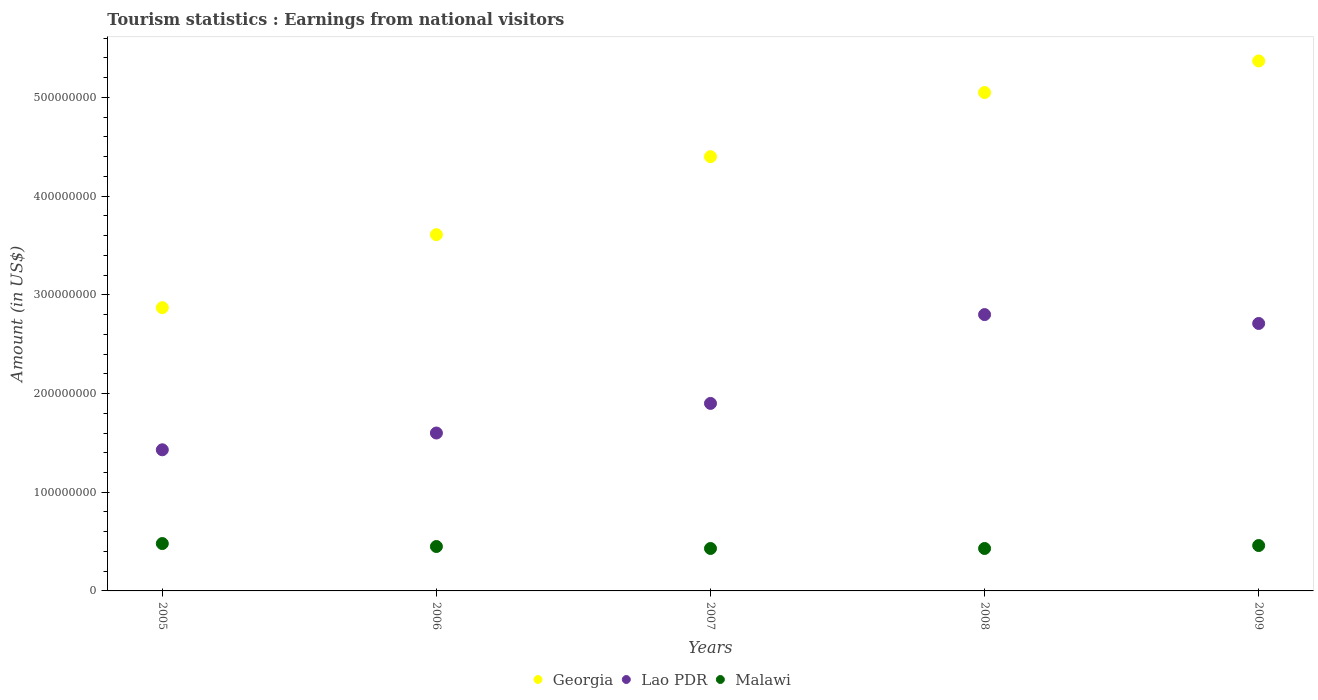What is the earnings from national visitors in Georgia in 2009?
Provide a succinct answer. 5.37e+08. Across all years, what is the maximum earnings from national visitors in Malawi?
Offer a terse response. 4.80e+07. Across all years, what is the minimum earnings from national visitors in Lao PDR?
Your answer should be compact. 1.43e+08. What is the total earnings from national visitors in Malawi in the graph?
Your answer should be compact. 2.25e+08. What is the difference between the earnings from national visitors in Lao PDR in 2006 and that in 2008?
Your answer should be very brief. -1.20e+08. What is the difference between the earnings from national visitors in Georgia in 2006 and the earnings from national visitors in Lao PDR in 2005?
Ensure brevity in your answer.  2.18e+08. What is the average earnings from national visitors in Georgia per year?
Provide a succinct answer. 4.26e+08. In the year 2005, what is the difference between the earnings from national visitors in Malawi and earnings from national visitors in Lao PDR?
Offer a very short reply. -9.50e+07. What is the ratio of the earnings from national visitors in Georgia in 2006 to that in 2008?
Offer a very short reply. 0.71. Is the difference between the earnings from national visitors in Malawi in 2007 and 2008 greater than the difference between the earnings from national visitors in Lao PDR in 2007 and 2008?
Ensure brevity in your answer.  Yes. What is the difference between the highest and the second highest earnings from national visitors in Georgia?
Make the answer very short. 3.20e+07. What is the difference between the highest and the lowest earnings from national visitors in Georgia?
Offer a very short reply. 2.50e+08. Is the sum of the earnings from national visitors in Georgia in 2005 and 2009 greater than the maximum earnings from national visitors in Malawi across all years?
Provide a short and direct response. Yes. Is the earnings from national visitors in Malawi strictly greater than the earnings from national visitors in Lao PDR over the years?
Your answer should be compact. No. How many dotlines are there?
Offer a terse response. 3. How many years are there in the graph?
Offer a very short reply. 5. What is the difference between two consecutive major ticks on the Y-axis?
Give a very brief answer. 1.00e+08. Does the graph contain grids?
Keep it short and to the point. No. Where does the legend appear in the graph?
Your response must be concise. Bottom center. What is the title of the graph?
Keep it short and to the point. Tourism statistics : Earnings from national visitors. What is the label or title of the X-axis?
Provide a short and direct response. Years. What is the Amount (in US$) of Georgia in 2005?
Keep it short and to the point. 2.87e+08. What is the Amount (in US$) in Lao PDR in 2005?
Your answer should be very brief. 1.43e+08. What is the Amount (in US$) in Malawi in 2005?
Give a very brief answer. 4.80e+07. What is the Amount (in US$) of Georgia in 2006?
Keep it short and to the point. 3.61e+08. What is the Amount (in US$) in Lao PDR in 2006?
Offer a terse response. 1.60e+08. What is the Amount (in US$) of Malawi in 2006?
Your answer should be very brief. 4.50e+07. What is the Amount (in US$) of Georgia in 2007?
Ensure brevity in your answer.  4.40e+08. What is the Amount (in US$) of Lao PDR in 2007?
Offer a very short reply. 1.90e+08. What is the Amount (in US$) of Malawi in 2007?
Give a very brief answer. 4.30e+07. What is the Amount (in US$) in Georgia in 2008?
Offer a terse response. 5.05e+08. What is the Amount (in US$) in Lao PDR in 2008?
Your answer should be compact. 2.80e+08. What is the Amount (in US$) in Malawi in 2008?
Provide a succinct answer. 4.30e+07. What is the Amount (in US$) in Georgia in 2009?
Your response must be concise. 5.37e+08. What is the Amount (in US$) in Lao PDR in 2009?
Keep it short and to the point. 2.71e+08. What is the Amount (in US$) of Malawi in 2009?
Provide a succinct answer. 4.60e+07. Across all years, what is the maximum Amount (in US$) of Georgia?
Offer a terse response. 5.37e+08. Across all years, what is the maximum Amount (in US$) in Lao PDR?
Ensure brevity in your answer.  2.80e+08. Across all years, what is the maximum Amount (in US$) in Malawi?
Provide a succinct answer. 4.80e+07. Across all years, what is the minimum Amount (in US$) in Georgia?
Give a very brief answer. 2.87e+08. Across all years, what is the minimum Amount (in US$) in Lao PDR?
Offer a very short reply. 1.43e+08. Across all years, what is the minimum Amount (in US$) in Malawi?
Your answer should be very brief. 4.30e+07. What is the total Amount (in US$) of Georgia in the graph?
Keep it short and to the point. 2.13e+09. What is the total Amount (in US$) of Lao PDR in the graph?
Offer a very short reply. 1.04e+09. What is the total Amount (in US$) of Malawi in the graph?
Offer a terse response. 2.25e+08. What is the difference between the Amount (in US$) in Georgia in 2005 and that in 2006?
Provide a succinct answer. -7.40e+07. What is the difference between the Amount (in US$) in Lao PDR in 2005 and that in 2006?
Offer a very short reply. -1.70e+07. What is the difference between the Amount (in US$) in Georgia in 2005 and that in 2007?
Give a very brief answer. -1.53e+08. What is the difference between the Amount (in US$) in Lao PDR in 2005 and that in 2007?
Keep it short and to the point. -4.70e+07. What is the difference between the Amount (in US$) in Georgia in 2005 and that in 2008?
Keep it short and to the point. -2.18e+08. What is the difference between the Amount (in US$) in Lao PDR in 2005 and that in 2008?
Your answer should be very brief. -1.37e+08. What is the difference between the Amount (in US$) of Malawi in 2005 and that in 2008?
Offer a very short reply. 5.00e+06. What is the difference between the Amount (in US$) in Georgia in 2005 and that in 2009?
Keep it short and to the point. -2.50e+08. What is the difference between the Amount (in US$) of Lao PDR in 2005 and that in 2009?
Keep it short and to the point. -1.28e+08. What is the difference between the Amount (in US$) of Georgia in 2006 and that in 2007?
Provide a short and direct response. -7.90e+07. What is the difference between the Amount (in US$) of Lao PDR in 2006 and that in 2007?
Offer a terse response. -3.00e+07. What is the difference between the Amount (in US$) of Georgia in 2006 and that in 2008?
Your answer should be compact. -1.44e+08. What is the difference between the Amount (in US$) in Lao PDR in 2006 and that in 2008?
Give a very brief answer. -1.20e+08. What is the difference between the Amount (in US$) of Malawi in 2006 and that in 2008?
Keep it short and to the point. 2.00e+06. What is the difference between the Amount (in US$) of Georgia in 2006 and that in 2009?
Ensure brevity in your answer.  -1.76e+08. What is the difference between the Amount (in US$) of Lao PDR in 2006 and that in 2009?
Your answer should be compact. -1.11e+08. What is the difference between the Amount (in US$) of Malawi in 2006 and that in 2009?
Your answer should be compact. -1.00e+06. What is the difference between the Amount (in US$) of Georgia in 2007 and that in 2008?
Your response must be concise. -6.50e+07. What is the difference between the Amount (in US$) in Lao PDR in 2007 and that in 2008?
Provide a short and direct response. -9.00e+07. What is the difference between the Amount (in US$) in Georgia in 2007 and that in 2009?
Make the answer very short. -9.70e+07. What is the difference between the Amount (in US$) of Lao PDR in 2007 and that in 2009?
Give a very brief answer. -8.10e+07. What is the difference between the Amount (in US$) in Malawi in 2007 and that in 2009?
Your response must be concise. -3.00e+06. What is the difference between the Amount (in US$) in Georgia in 2008 and that in 2009?
Your response must be concise. -3.20e+07. What is the difference between the Amount (in US$) of Lao PDR in 2008 and that in 2009?
Your answer should be very brief. 9.00e+06. What is the difference between the Amount (in US$) in Malawi in 2008 and that in 2009?
Make the answer very short. -3.00e+06. What is the difference between the Amount (in US$) of Georgia in 2005 and the Amount (in US$) of Lao PDR in 2006?
Keep it short and to the point. 1.27e+08. What is the difference between the Amount (in US$) of Georgia in 2005 and the Amount (in US$) of Malawi in 2006?
Provide a succinct answer. 2.42e+08. What is the difference between the Amount (in US$) in Lao PDR in 2005 and the Amount (in US$) in Malawi in 2006?
Provide a short and direct response. 9.80e+07. What is the difference between the Amount (in US$) of Georgia in 2005 and the Amount (in US$) of Lao PDR in 2007?
Make the answer very short. 9.70e+07. What is the difference between the Amount (in US$) in Georgia in 2005 and the Amount (in US$) in Malawi in 2007?
Your answer should be very brief. 2.44e+08. What is the difference between the Amount (in US$) of Georgia in 2005 and the Amount (in US$) of Malawi in 2008?
Give a very brief answer. 2.44e+08. What is the difference between the Amount (in US$) of Georgia in 2005 and the Amount (in US$) of Lao PDR in 2009?
Provide a succinct answer. 1.60e+07. What is the difference between the Amount (in US$) of Georgia in 2005 and the Amount (in US$) of Malawi in 2009?
Provide a short and direct response. 2.41e+08. What is the difference between the Amount (in US$) of Lao PDR in 2005 and the Amount (in US$) of Malawi in 2009?
Provide a short and direct response. 9.70e+07. What is the difference between the Amount (in US$) in Georgia in 2006 and the Amount (in US$) in Lao PDR in 2007?
Make the answer very short. 1.71e+08. What is the difference between the Amount (in US$) in Georgia in 2006 and the Amount (in US$) in Malawi in 2007?
Your answer should be very brief. 3.18e+08. What is the difference between the Amount (in US$) of Lao PDR in 2006 and the Amount (in US$) of Malawi in 2007?
Offer a very short reply. 1.17e+08. What is the difference between the Amount (in US$) in Georgia in 2006 and the Amount (in US$) in Lao PDR in 2008?
Your answer should be compact. 8.10e+07. What is the difference between the Amount (in US$) of Georgia in 2006 and the Amount (in US$) of Malawi in 2008?
Your answer should be compact. 3.18e+08. What is the difference between the Amount (in US$) of Lao PDR in 2006 and the Amount (in US$) of Malawi in 2008?
Make the answer very short. 1.17e+08. What is the difference between the Amount (in US$) in Georgia in 2006 and the Amount (in US$) in Lao PDR in 2009?
Give a very brief answer. 9.00e+07. What is the difference between the Amount (in US$) of Georgia in 2006 and the Amount (in US$) of Malawi in 2009?
Provide a short and direct response. 3.15e+08. What is the difference between the Amount (in US$) in Lao PDR in 2006 and the Amount (in US$) in Malawi in 2009?
Offer a very short reply. 1.14e+08. What is the difference between the Amount (in US$) of Georgia in 2007 and the Amount (in US$) of Lao PDR in 2008?
Your answer should be compact. 1.60e+08. What is the difference between the Amount (in US$) of Georgia in 2007 and the Amount (in US$) of Malawi in 2008?
Give a very brief answer. 3.97e+08. What is the difference between the Amount (in US$) of Lao PDR in 2007 and the Amount (in US$) of Malawi in 2008?
Offer a terse response. 1.47e+08. What is the difference between the Amount (in US$) of Georgia in 2007 and the Amount (in US$) of Lao PDR in 2009?
Offer a terse response. 1.69e+08. What is the difference between the Amount (in US$) in Georgia in 2007 and the Amount (in US$) in Malawi in 2009?
Your answer should be very brief. 3.94e+08. What is the difference between the Amount (in US$) in Lao PDR in 2007 and the Amount (in US$) in Malawi in 2009?
Ensure brevity in your answer.  1.44e+08. What is the difference between the Amount (in US$) in Georgia in 2008 and the Amount (in US$) in Lao PDR in 2009?
Make the answer very short. 2.34e+08. What is the difference between the Amount (in US$) of Georgia in 2008 and the Amount (in US$) of Malawi in 2009?
Provide a succinct answer. 4.59e+08. What is the difference between the Amount (in US$) in Lao PDR in 2008 and the Amount (in US$) in Malawi in 2009?
Provide a succinct answer. 2.34e+08. What is the average Amount (in US$) in Georgia per year?
Your answer should be very brief. 4.26e+08. What is the average Amount (in US$) of Lao PDR per year?
Offer a terse response. 2.09e+08. What is the average Amount (in US$) in Malawi per year?
Make the answer very short. 4.50e+07. In the year 2005, what is the difference between the Amount (in US$) of Georgia and Amount (in US$) of Lao PDR?
Ensure brevity in your answer.  1.44e+08. In the year 2005, what is the difference between the Amount (in US$) in Georgia and Amount (in US$) in Malawi?
Make the answer very short. 2.39e+08. In the year 2005, what is the difference between the Amount (in US$) in Lao PDR and Amount (in US$) in Malawi?
Your answer should be compact. 9.50e+07. In the year 2006, what is the difference between the Amount (in US$) in Georgia and Amount (in US$) in Lao PDR?
Provide a short and direct response. 2.01e+08. In the year 2006, what is the difference between the Amount (in US$) in Georgia and Amount (in US$) in Malawi?
Offer a very short reply. 3.16e+08. In the year 2006, what is the difference between the Amount (in US$) in Lao PDR and Amount (in US$) in Malawi?
Your answer should be compact. 1.15e+08. In the year 2007, what is the difference between the Amount (in US$) of Georgia and Amount (in US$) of Lao PDR?
Your answer should be compact. 2.50e+08. In the year 2007, what is the difference between the Amount (in US$) in Georgia and Amount (in US$) in Malawi?
Provide a short and direct response. 3.97e+08. In the year 2007, what is the difference between the Amount (in US$) of Lao PDR and Amount (in US$) of Malawi?
Your answer should be compact. 1.47e+08. In the year 2008, what is the difference between the Amount (in US$) of Georgia and Amount (in US$) of Lao PDR?
Keep it short and to the point. 2.25e+08. In the year 2008, what is the difference between the Amount (in US$) in Georgia and Amount (in US$) in Malawi?
Make the answer very short. 4.62e+08. In the year 2008, what is the difference between the Amount (in US$) in Lao PDR and Amount (in US$) in Malawi?
Your response must be concise. 2.37e+08. In the year 2009, what is the difference between the Amount (in US$) in Georgia and Amount (in US$) in Lao PDR?
Give a very brief answer. 2.66e+08. In the year 2009, what is the difference between the Amount (in US$) of Georgia and Amount (in US$) of Malawi?
Provide a short and direct response. 4.91e+08. In the year 2009, what is the difference between the Amount (in US$) in Lao PDR and Amount (in US$) in Malawi?
Your response must be concise. 2.25e+08. What is the ratio of the Amount (in US$) of Georgia in 2005 to that in 2006?
Provide a succinct answer. 0.8. What is the ratio of the Amount (in US$) of Lao PDR in 2005 to that in 2006?
Give a very brief answer. 0.89. What is the ratio of the Amount (in US$) in Malawi in 2005 to that in 2006?
Offer a terse response. 1.07. What is the ratio of the Amount (in US$) of Georgia in 2005 to that in 2007?
Your answer should be very brief. 0.65. What is the ratio of the Amount (in US$) of Lao PDR in 2005 to that in 2007?
Your answer should be very brief. 0.75. What is the ratio of the Amount (in US$) in Malawi in 2005 to that in 2007?
Give a very brief answer. 1.12. What is the ratio of the Amount (in US$) of Georgia in 2005 to that in 2008?
Provide a succinct answer. 0.57. What is the ratio of the Amount (in US$) of Lao PDR in 2005 to that in 2008?
Offer a terse response. 0.51. What is the ratio of the Amount (in US$) in Malawi in 2005 to that in 2008?
Make the answer very short. 1.12. What is the ratio of the Amount (in US$) of Georgia in 2005 to that in 2009?
Offer a very short reply. 0.53. What is the ratio of the Amount (in US$) of Lao PDR in 2005 to that in 2009?
Provide a succinct answer. 0.53. What is the ratio of the Amount (in US$) of Malawi in 2005 to that in 2009?
Provide a succinct answer. 1.04. What is the ratio of the Amount (in US$) in Georgia in 2006 to that in 2007?
Offer a terse response. 0.82. What is the ratio of the Amount (in US$) in Lao PDR in 2006 to that in 2007?
Keep it short and to the point. 0.84. What is the ratio of the Amount (in US$) of Malawi in 2006 to that in 2007?
Provide a short and direct response. 1.05. What is the ratio of the Amount (in US$) of Georgia in 2006 to that in 2008?
Your answer should be compact. 0.71. What is the ratio of the Amount (in US$) in Lao PDR in 2006 to that in 2008?
Your answer should be compact. 0.57. What is the ratio of the Amount (in US$) of Malawi in 2006 to that in 2008?
Keep it short and to the point. 1.05. What is the ratio of the Amount (in US$) of Georgia in 2006 to that in 2009?
Keep it short and to the point. 0.67. What is the ratio of the Amount (in US$) in Lao PDR in 2006 to that in 2009?
Make the answer very short. 0.59. What is the ratio of the Amount (in US$) of Malawi in 2006 to that in 2009?
Give a very brief answer. 0.98. What is the ratio of the Amount (in US$) of Georgia in 2007 to that in 2008?
Offer a terse response. 0.87. What is the ratio of the Amount (in US$) in Lao PDR in 2007 to that in 2008?
Your response must be concise. 0.68. What is the ratio of the Amount (in US$) in Malawi in 2007 to that in 2008?
Your answer should be compact. 1. What is the ratio of the Amount (in US$) in Georgia in 2007 to that in 2009?
Ensure brevity in your answer.  0.82. What is the ratio of the Amount (in US$) of Lao PDR in 2007 to that in 2009?
Ensure brevity in your answer.  0.7. What is the ratio of the Amount (in US$) of Malawi in 2007 to that in 2009?
Offer a very short reply. 0.93. What is the ratio of the Amount (in US$) in Georgia in 2008 to that in 2009?
Keep it short and to the point. 0.94. What is the ratio of the Amount (in US$) of Lao PDR in 2008 to that in 2009?
Your answer should be compact. 1.03. What is the ratio of the Amount (in US$) in Malawi in 2008 to that in 2009?
Give a very brief answer. 0.93. What is the difference between the highest and the second highest Amount (in US$) in Georgia?
Provide a short and direct response. 3.20e+07. What is the difference between the highest and the second highest Amount (in US$) in Lao PDR?
Provide a short and direct response. 9.00e+06. What is the difference between the highest and the second highest Amount (in US$) of Malawi?
Provide a succinct answer. 2.00e+06. What is the difference between the highest and the lowest Amount (in US$) in Georgia?
Provide a succinct answer. 2.50e+08. What is the difference between the highest and the lowest Amount (in US$) of Lao PDR?
Offer a very short reply. 1.37e+08. What is the difference between the highest and the lowest Amount (in US$) in Malawi?
Make the answer very short. 5.00e+06. 